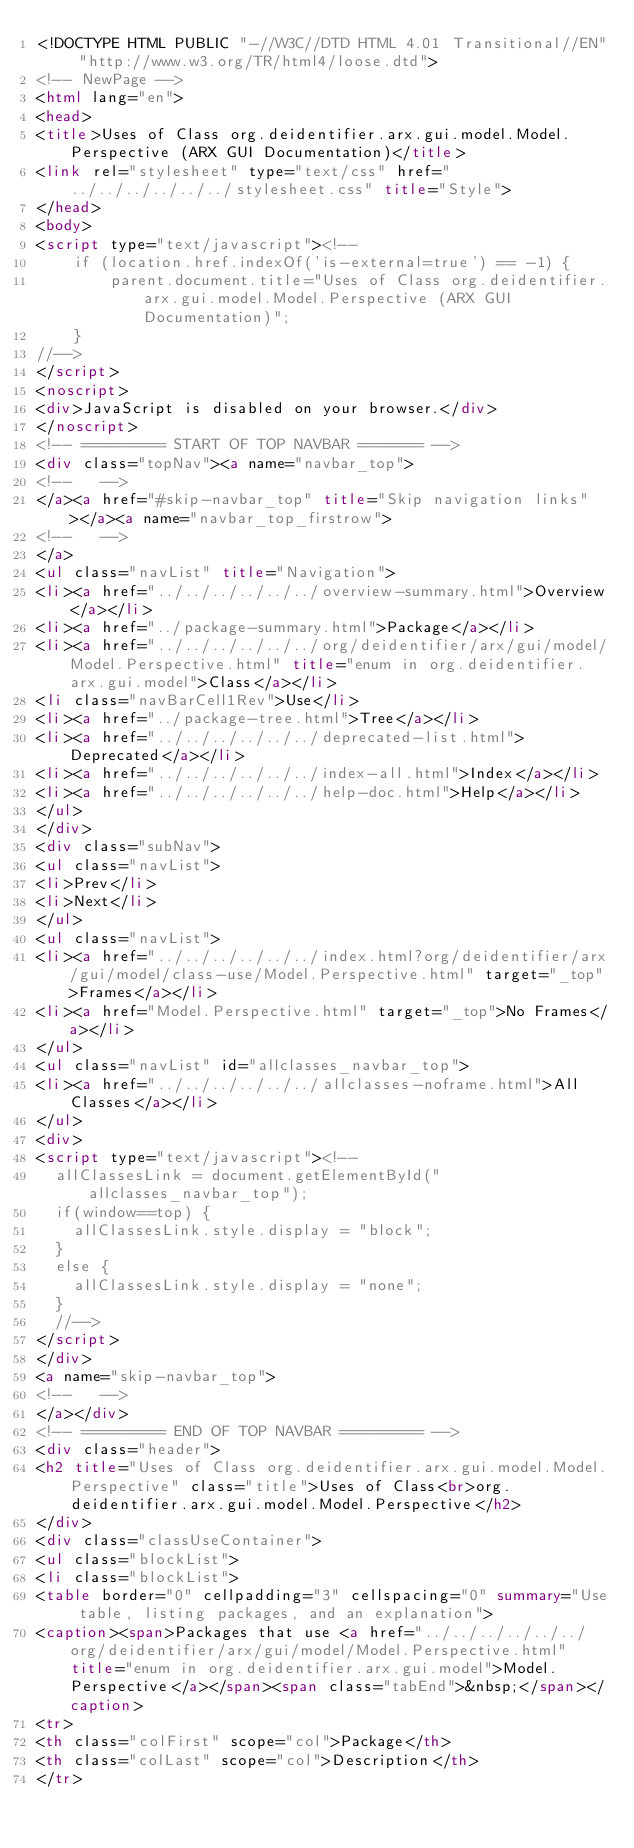<code> <loc_0><loc_0><loc_500><loc_500><_HTML_><!DOCTYPE HTML PUBLIC "-//W3C//DTD HTML 4.01 Transitional//EN" "http://www.w3.org/TR/html4/loose.dtd">
<!-- NewPage -->
<html lang="en">
<head>
<title>Uses of Class org.deidentifier.arx.gui.model.Model.Perspective (ARX GUI Documentation)</title>
<link rel="stylesheet" type="text/css" href="../../../../../../stylesheet.css" title="Style">
</head>
<body>
<script type="text/javascript"><!--
    if (location.href.indexOf('is-external=true') == -1) {
        parent.document.title="Uses of Class org.deidentifier.arx.gui.model.Model.Perspective (ARX GUI Documentation)";
    }
//-->
</script>
<noscript>
<div>JavaScript is disabled on your browser.</div>
</noscript>
<!-- ========= START OF TOP NAVBAR ======= -->
<div class="topNav"><a name="navbar_top">
<!--   -->
</a><a href="#skip-navbar_top" title="Skip navigation links"></a><a name="navbar_top_firstrow">
<!--   -->
</a>
<ul class="navList" title="Navigation">
<li><a href="../../../../../../overview-summary.html">Overview</a></li>
<li><a href="../package-summary.html">Package</a></li>
<li><a href="../../../../../../org/deidentifier/arx/gui/model/Model.Perspective.html" title="enum in org.deidentifier.arx.gui.model">Class</a></li>
<li class="navBarCell1Rev">Use</li>
<li><a href="../package-tree.html">Tree</a></li>
<li><a href="../../../../../../deprecated-list.html">Deprecated</a></li>
<li><a href="../../../../../../index-all.html">Index</a></li>
<li><a href="../../../../../../help-doc.html">Help</a></li>
</ul>
</div>
<div class="subNav">
<ul class="navList">
<li>Prev</li>
<li>Next</li>
</ul>
<ul class="navList">
<li><a href="../../../../../../index.html?org/deidentifier/arx/gui/model/class-use/Model.Perspective.html" target="_top">Frames</a></li>
<li><a href="Model.Perspective.html" target="_top">No Frames</a></li>
</ul>
<ul class="navList" id="allclasses_navbar_top">
<li><a href="../../../../../../allclasses-noframe.html">All Classes</a></li>
</ul>
<div>
<script type="text/javascript"><!--
  allClassesLink = document.getElementById("allclasses_navbar_top");
  if(window==top) {
    allClassesLink.style.display = "block";
  }
  else {
    allClassesLink.style.display = "none";
  }
  //-->
</script>
</div>
<a name="skip-navbar_top">
<!--   -->
</a></div>
<!-- ========= END OF TOP NAVBAR ========= -->
<div class="header">
<h2 title="Uses of Class org.deidentifier.arx.gui.model.Model.Perspective" class="title">Uses of Class<br>org.deidentifier.arx.gui.model.Model.Perspective</h2>
</div>
<div class="classUseContainer">
<ul class="blockList">
<li class="blockList">
<table border="0" cellpadding="3" cellspacing="0" summary="Use table, listing packages, and an explanation">
<caption><span>Packages that use <a href="../../../../../../org/deidentifier/arx/gui/model/Model.Perspective.html" title="enum in org.deidentifier.arx.gui.model">Model.Perspective</a></span><span class="tabEnd">&nbsp;</span></caption>
<tr>
<th class="colFirst" scope="col">Package</th>
<th class="colLast" scope="col">Description</th>
</tr></code> 